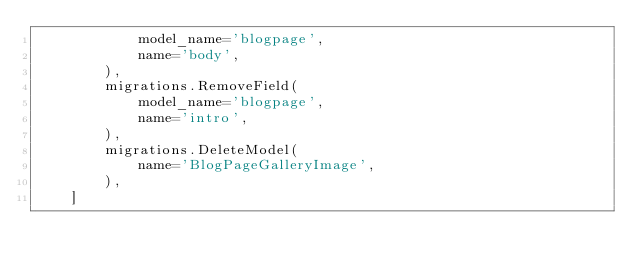<code> <loc_0><loc_0><loc_500><loc_500><_Python_>            model_name='blogpage',
            name='body',
        ),
        migrations.RemoveField(
            model_name='blogpage',
            name='intro',
        ),
        migrations.DeleteModel(
            name='BlogPageGalleryImage',
        ),
    ]
</code> 